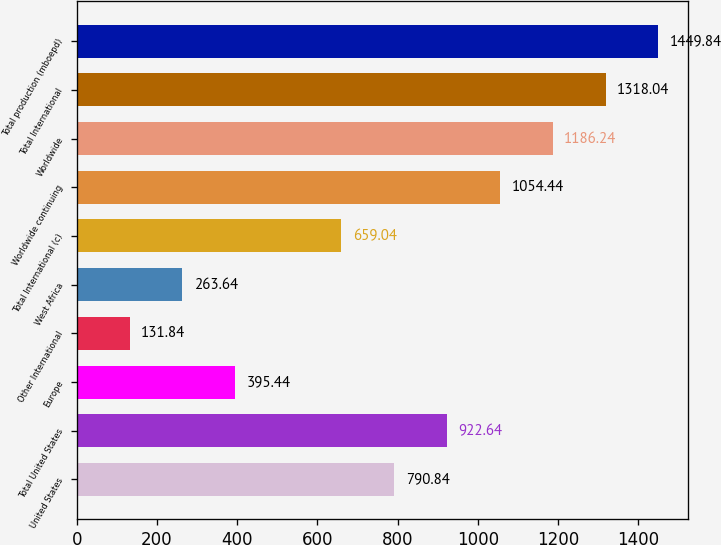Convert chart. <chart><loc_0><loc_0><loc_500><loc_500><bar_chart><fcel>United States<fcel>Total United States<fcel>Europe<fcel>Other International<fcel>West Africa<fcel>Total International (c)<fcel>Worldwide continuing<fcel>Worldwide<fcel>Total International<fcel>Total production (mboepd)<nl><fcel>790.84<fcel>922.64<fcel>395.44<fcel>131.84<fcel>263.64<fcel>659.04<fcel>1054.44<fcel>1186.24<fcel>1318.04<fcel>1449.84<nl></chart> 